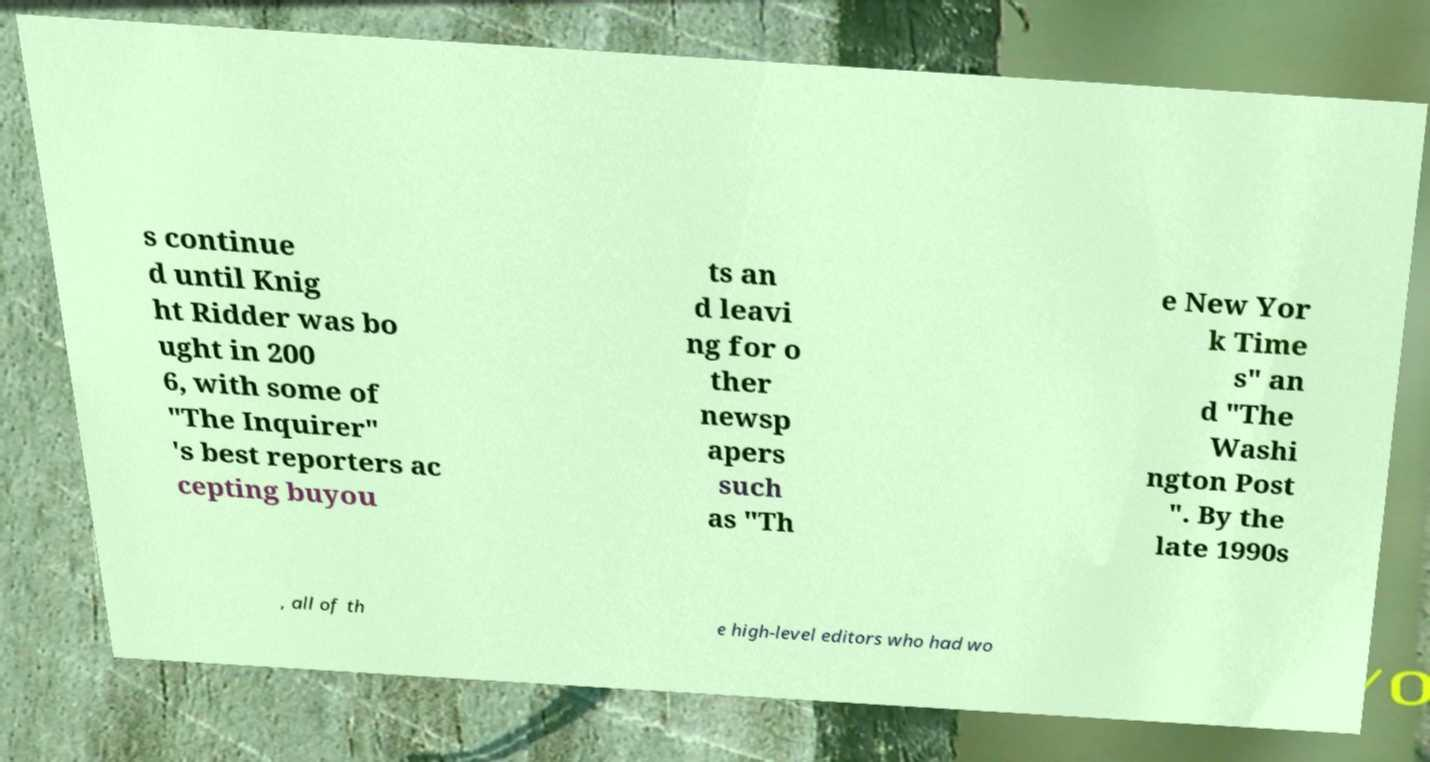Can you read and provide the text displayed in the image?This photo seems to have some interesting text. Can you extract and type it out for me? s continue d until Knig ht Ridder was bo ught in 200 6, with some of "The Inquirer" 's best reporters ac cepting buyou ts an d leavi ng for o ther newsp apers such as "Th e New Yor k Time s" an d "The Washi ngton Post ". By the late 1990s , all of th e high-level editors who had wo 